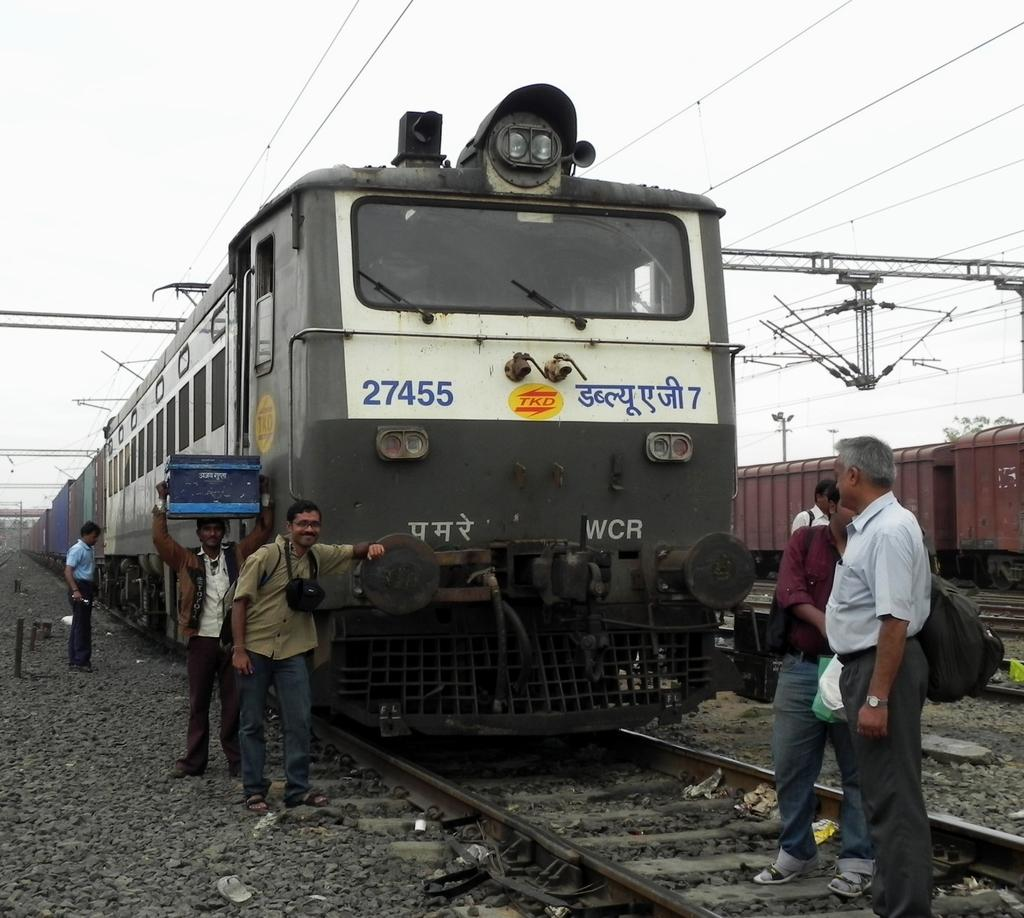What is the main subject of the image? The main subject of the image is trains on tracks. What are the people in the image doing? People are standing around the train in the image. What can be seen above the trains in the image? There are electrical wires at the top of the image. What is visible in the background of the image? The sky is visible in the image. What type of floor can be seen in the image? There is no floor visible in the image, as it features trains on tracks and people standing around them. What is the name of the yoke used by the train in the image? There is no yoke present in the image, as trains typically run on tracks and are not attached to a yoke. 